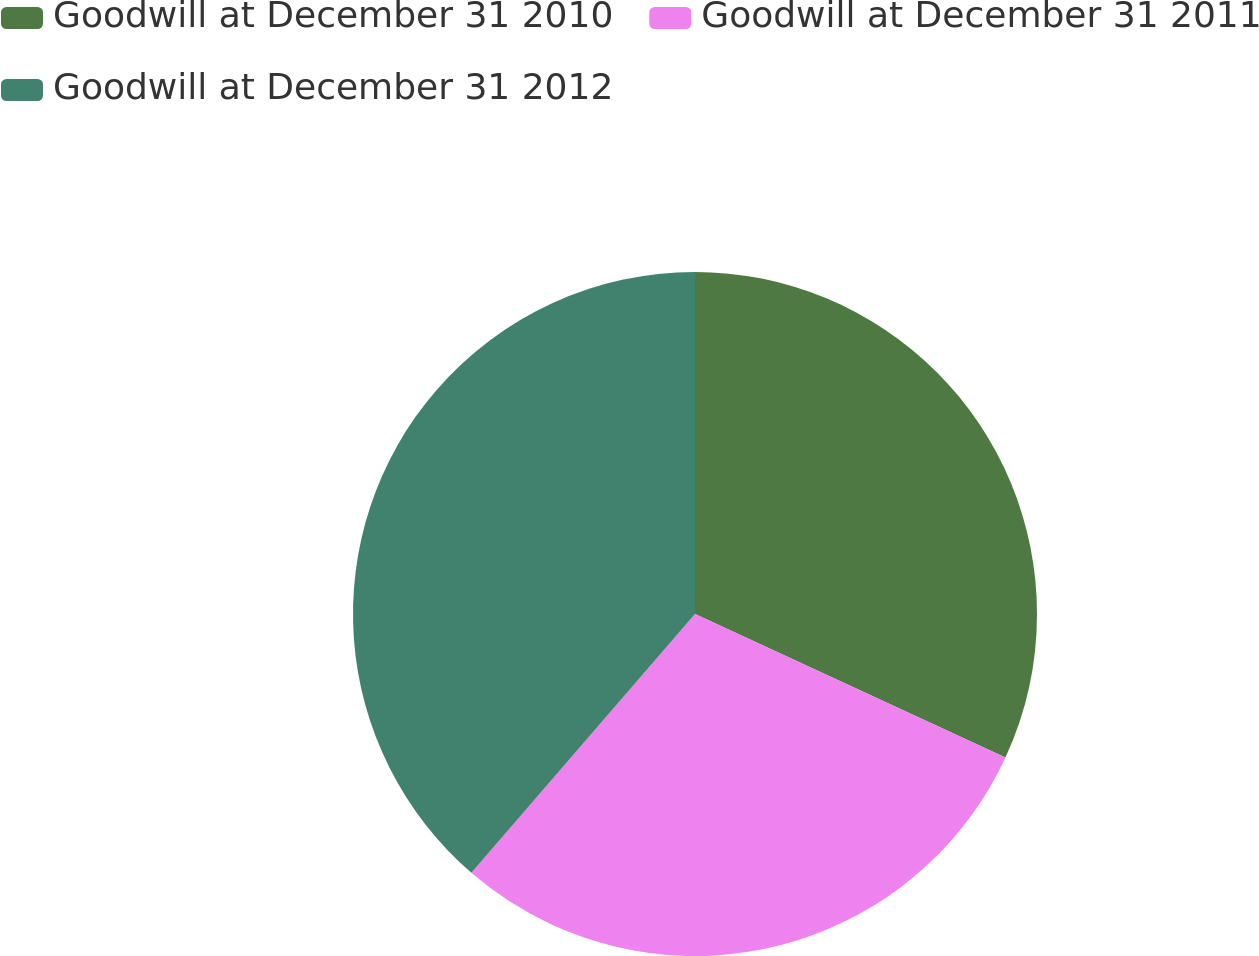<chart> <loc_0><loc_0><loc_500><loc_500><pie_chart><fcel>Goodwill at December 31 2010<fcel>Goodwill at December 31 2011<fcel>Goodwill at December 31 2012<nl><fcel>31.89%<fcel>29.45%<fcel>38.66%<nl></chart> 